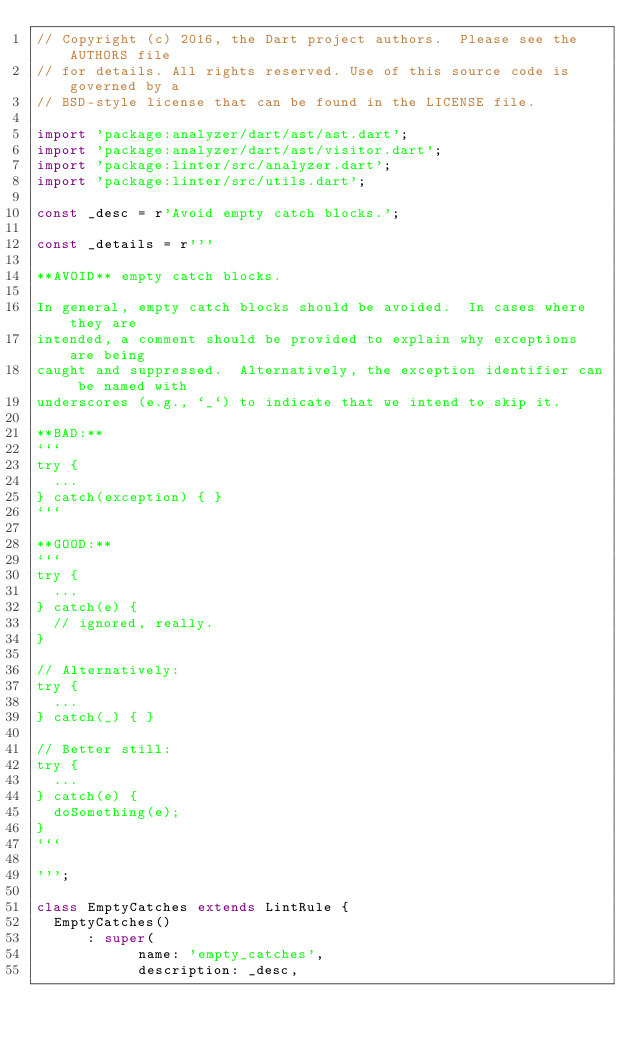<code> <loc_0><loc_0><loc_500><loc_500><_Dart_>// Copyright (c) 2016, the Dart project authors.  Please see the AUTHORS file
// for details. All rights reserved. Use of this source code is governed by a
// BSD-style license that can be found in the LICENSE file.

import 'package:analyzer/dart/ast/ast.dart';
import 'package:analyzer/dart/ast/visitor.dart';
import 'package:linter/src/analyzer.dart';
import 'package:linter/src/utils.dart';

const _desc = r'Avoid empty catch blocks.';

const _details = r'''

**AVOID** empty catch blocks.

In general, empty catch blocks should be avoided.  In cases where they are
intended, a comment should be provided to explain why exceptions are being
caught and suppressed.  Alternatively, the exception identifier can be named with
underscores (e.g., `_`) to indicate that we intend to skip it.

**BAD:**
```
try {
  ...
} catch(exception) { }
```

**GOOD:**
```
try {
  ...
} catch(e) {
  // ignored, really.
}

// Alternatively:
try {
  ...
} catch(_) { }

// Better still:
try {
  ...
} catch(e) {
  doSomething(e);
}
```

''';

class EmptyCatches extends LintRule {
  EmptyCatches()
      : super(
            name: 'empty_catches',
            description: _desc,</code> 